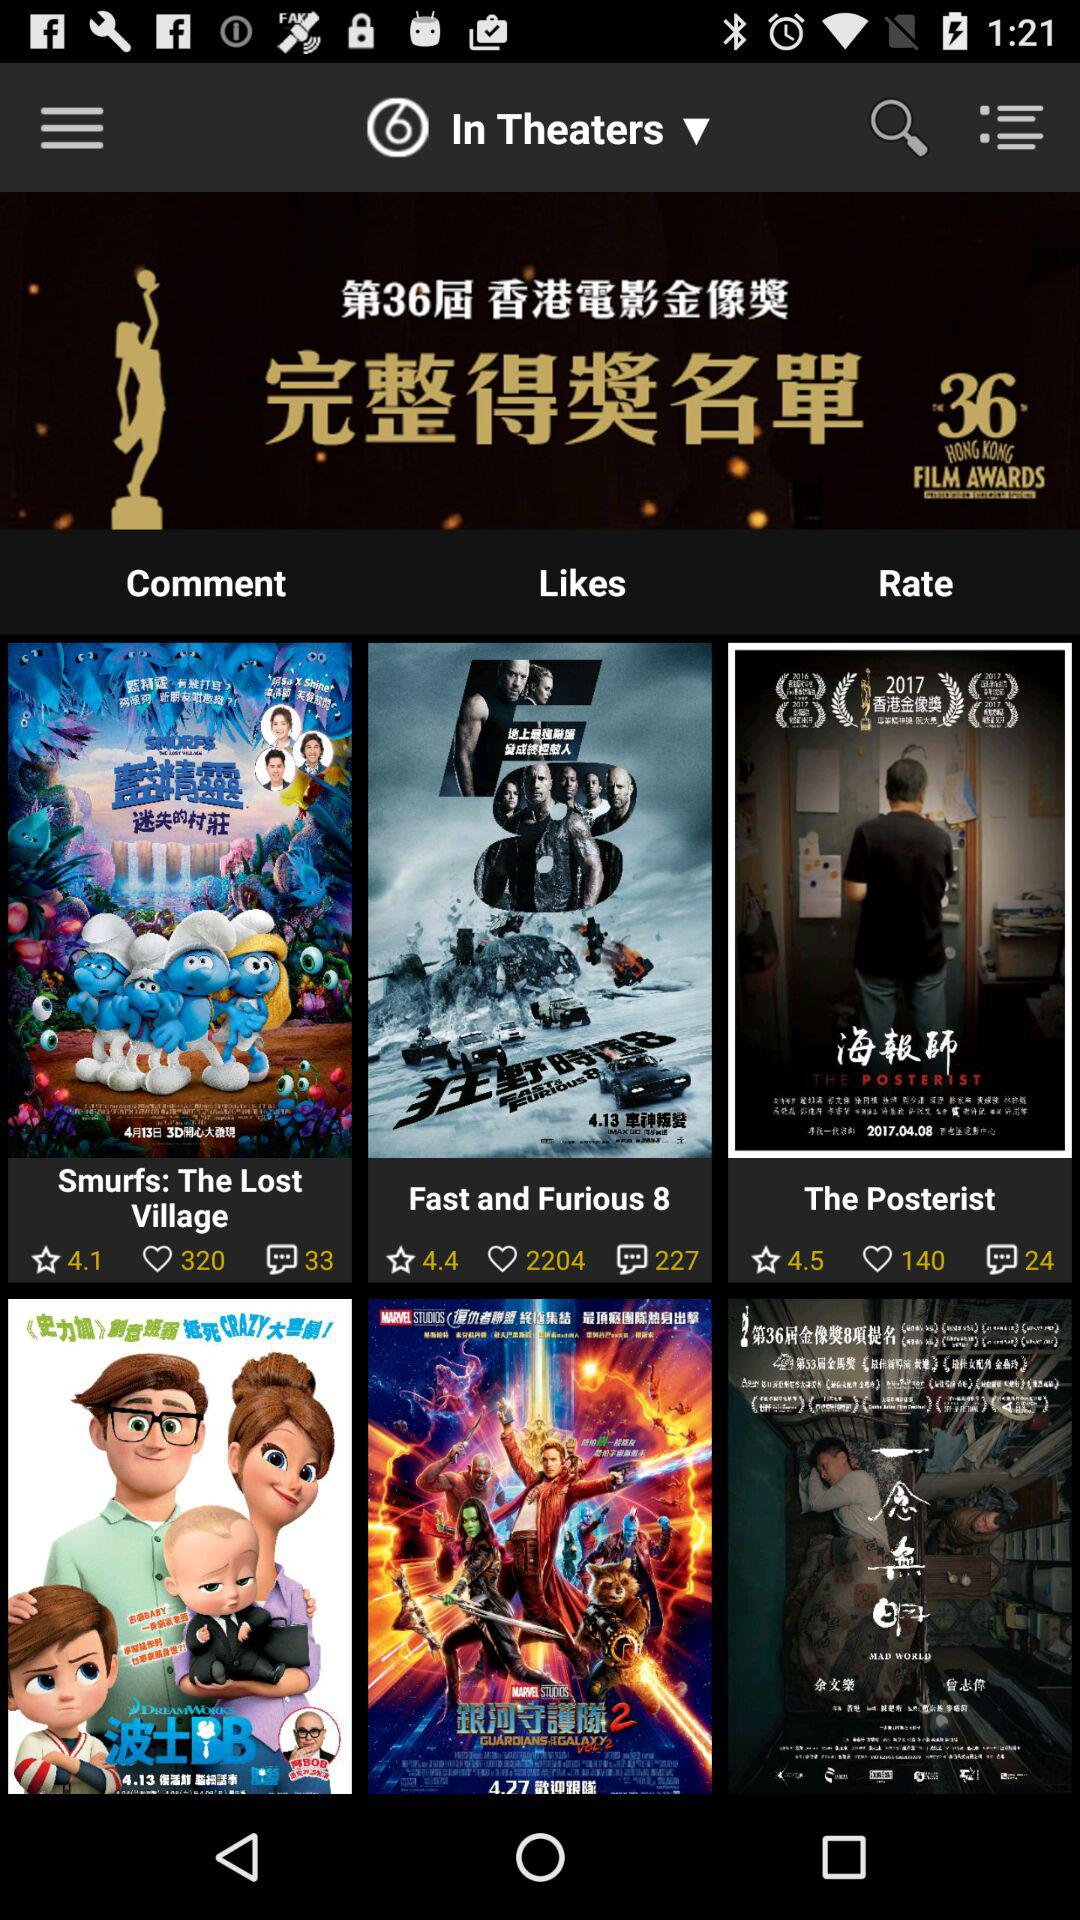How many likes are there for "The Posterist"? There are 140 likes. 